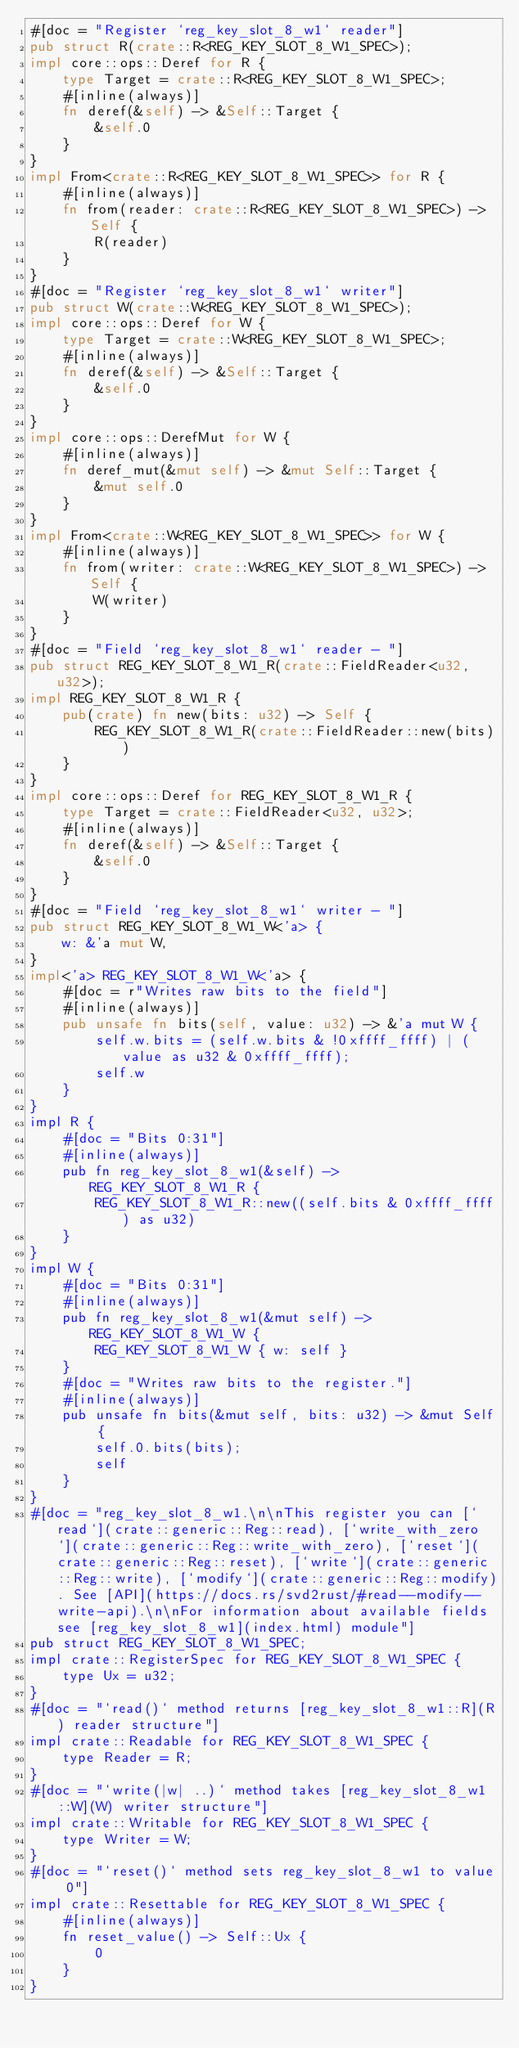Convert code to text. <code><loc_0><loc_0><loc_500><loc_500><_Rust_>#[doc = "Register `reg_key_slot_8_w1` reader"]
pub struct R(crate::R<REG_KEY_SLOT_8_W1_SPEC>);
impl core::ops::Deref for R {
    type Target = crate::R<REG_KEY_SLOT_8_W1_SPEC>;
    #[inline(always)]
    fn deref(&self) -> &Self::Target {
        &self.0
    }
}
impl From<crate::R<REG_KEY_SLOT_8_W1_SPEC>> for R {
    #[inline(always)]
    fn from(reader: crate::R<REG_KEY_SLOT_8_W1_SPEC>) -> Self {
        R(reader)
    }
}
#[doc = "Register `reg_key_slot_8_w1` writer"]
pub struct W(crate::W<REG_KEY_SLOT_8_W1_SPEC>);
impl core::ops::Deref for W {
    type Target = crate::W<REG_KEY_SLOT_8_W1_SPEC>;
    #[inline(always)]
    fn deref(&self) -> &Self::Target {
        &self.0
    }
}
impl core::ops::DerefMut for W {
    #[inline(always)]
    fn deref_mut(&mut self) -> &mut Self::Target {
        &mut self.0
    }
}
impl From<crate::W<REG_KEY_SLOT_8_W1_SPEC>> for W {
    #[inline(always)]
    fn from(writer: crate::W<REG_KEY_SLOT_8_W1_SPEC>) -> Self {
        W(writer)
    }
}
#[doc = "Field `reg_key_slot_8_w1` reader - "]
pub struct REG_KEY_SLOT_8_W1_R(crate::FieldReader<u32, u32>);
impl REG_KEY_SLOT_8_W1_R {
    pub(crate) fn new(bits: u32) -> Self {
        REG_KEY_SLOT_8_W1_R(crate::FieldReader::new(bits))
    }
}
impl core::ops::Deref for REG_KEY_SLOT_8_W1_R {
    type Target = crate::FieldReader<u32, u32>;
    #[inline(always)]
    fn deref(&self) -> &Self::Target {
        &self.0
    }
}
#[doc = "Field `reg_key_slot_8_w1` writer - "]
pub struct REG_KEY_SLOT_8_W1_W<'a> {
    w: &'a mut W,
}
impl<'a> REG_KEY_SLOT_8_W1_W<'a> {
    #[doc = r"Writes raw bits to the field"]
    #[inline(always)]
    pub unsafe fn bits(self, value: u32) -> &'a mut W {
        self.w.bits = (self.w.bits & !0xffff_ffff) | (value as u32 & 0xffff_ffff);
        self.w
    }
}
impl R {
    #[doc = "Bits 0:31"]
    #[inline(always)]
    pub fn reg_key_slot_8_w1(&self) -> REG_KEY_SLOT_8_W1_R {
        REG_KEY_SLOT_8_W1_R::new((self.bits & 0xffff_ffff) as u32)
    }
}
impl W {
    #[doc = "Bits 0:31"]
    #[inline(always)]
    pub fn reg_key_slot_8_w1(&mut self) -> REG_KEY_SLOT_8_W1_W {
        REG_KEY_SLOT_8_W1_W { w: self }
    }
    #[doc = "Writes raw bits to the register."]
    #[inline(always)]
    pub unsafe fn bits(&mut self, bits: u32) -> &mut Self {
        self.0.bits(bits);
        self
    }
}
#[doc = "reg_key_slot_8_w1.\n\nThis register you can [`read`](crate::generic::Reg::read), [`write_with_zero`](crate::generic::Reg::write_with_zero), [`reset`](crate::generic::Reg::reset), [`write`](crate::generic::Reg::write), [`modify`](crate::generic::Reg::modify). See [API](https://docs.rs/svd2rust/#read--modify--write-api).\n\nFor information about available fields see [reg_key_slot_8_w1](index.html) module"]
pub struct REG_KEY_SLOT_8_W1_SPEC;
impl crate::RegisterSpec for REG_KEY_SLOT_8_W1_SPEC {
    type Ux = u32;
}
#[doc = "`read()` method returns [reg_key_slot_8_w1::R](R) reader structure"]
impl crate::Readable for REG_KEY_SLOT_8_W1_SPEC {
    type Reader = R;
}
#[doc = "`write(|w| ..)` method takes [reg_key_slot_8_w1::W](W) writer structure"]
impl crate::Writable for REG_KEY_SLOT_8_W1_SPEC {
    type Writer = W;
}
#[doc = "`reset()` method sets reg_key_slot_8_w1 to value 0"]
impl crate::Resettable for REG_KEY_SLOT_8_W1_SPEC {
    #[inline(always)]
    fn reset_value() -> Self::Ux {
        0
    }
}
</code> 